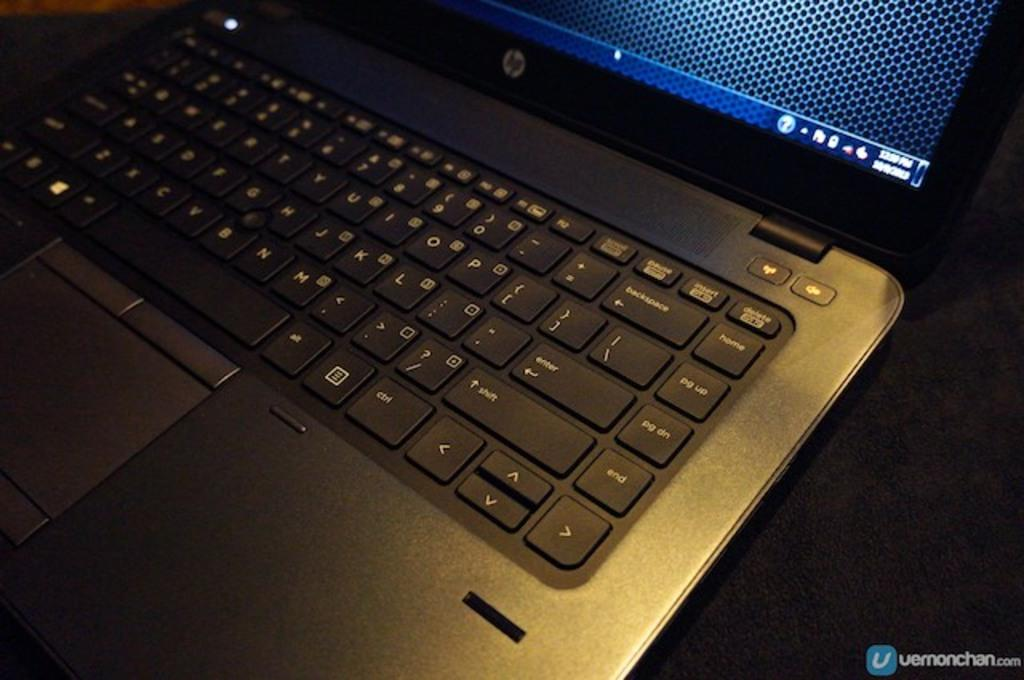<image>
Offer a succinct explanation of the picture presented. A laptop that is turned on with a HP logo on it. 